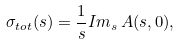<formula> <loc_0><loc_0><loc_500><loc_500>\sigma _ { t o t } ( s ) = \frac { 1 } { s } I m _ { s } \, A ( s , 0 ) ,</formula> 